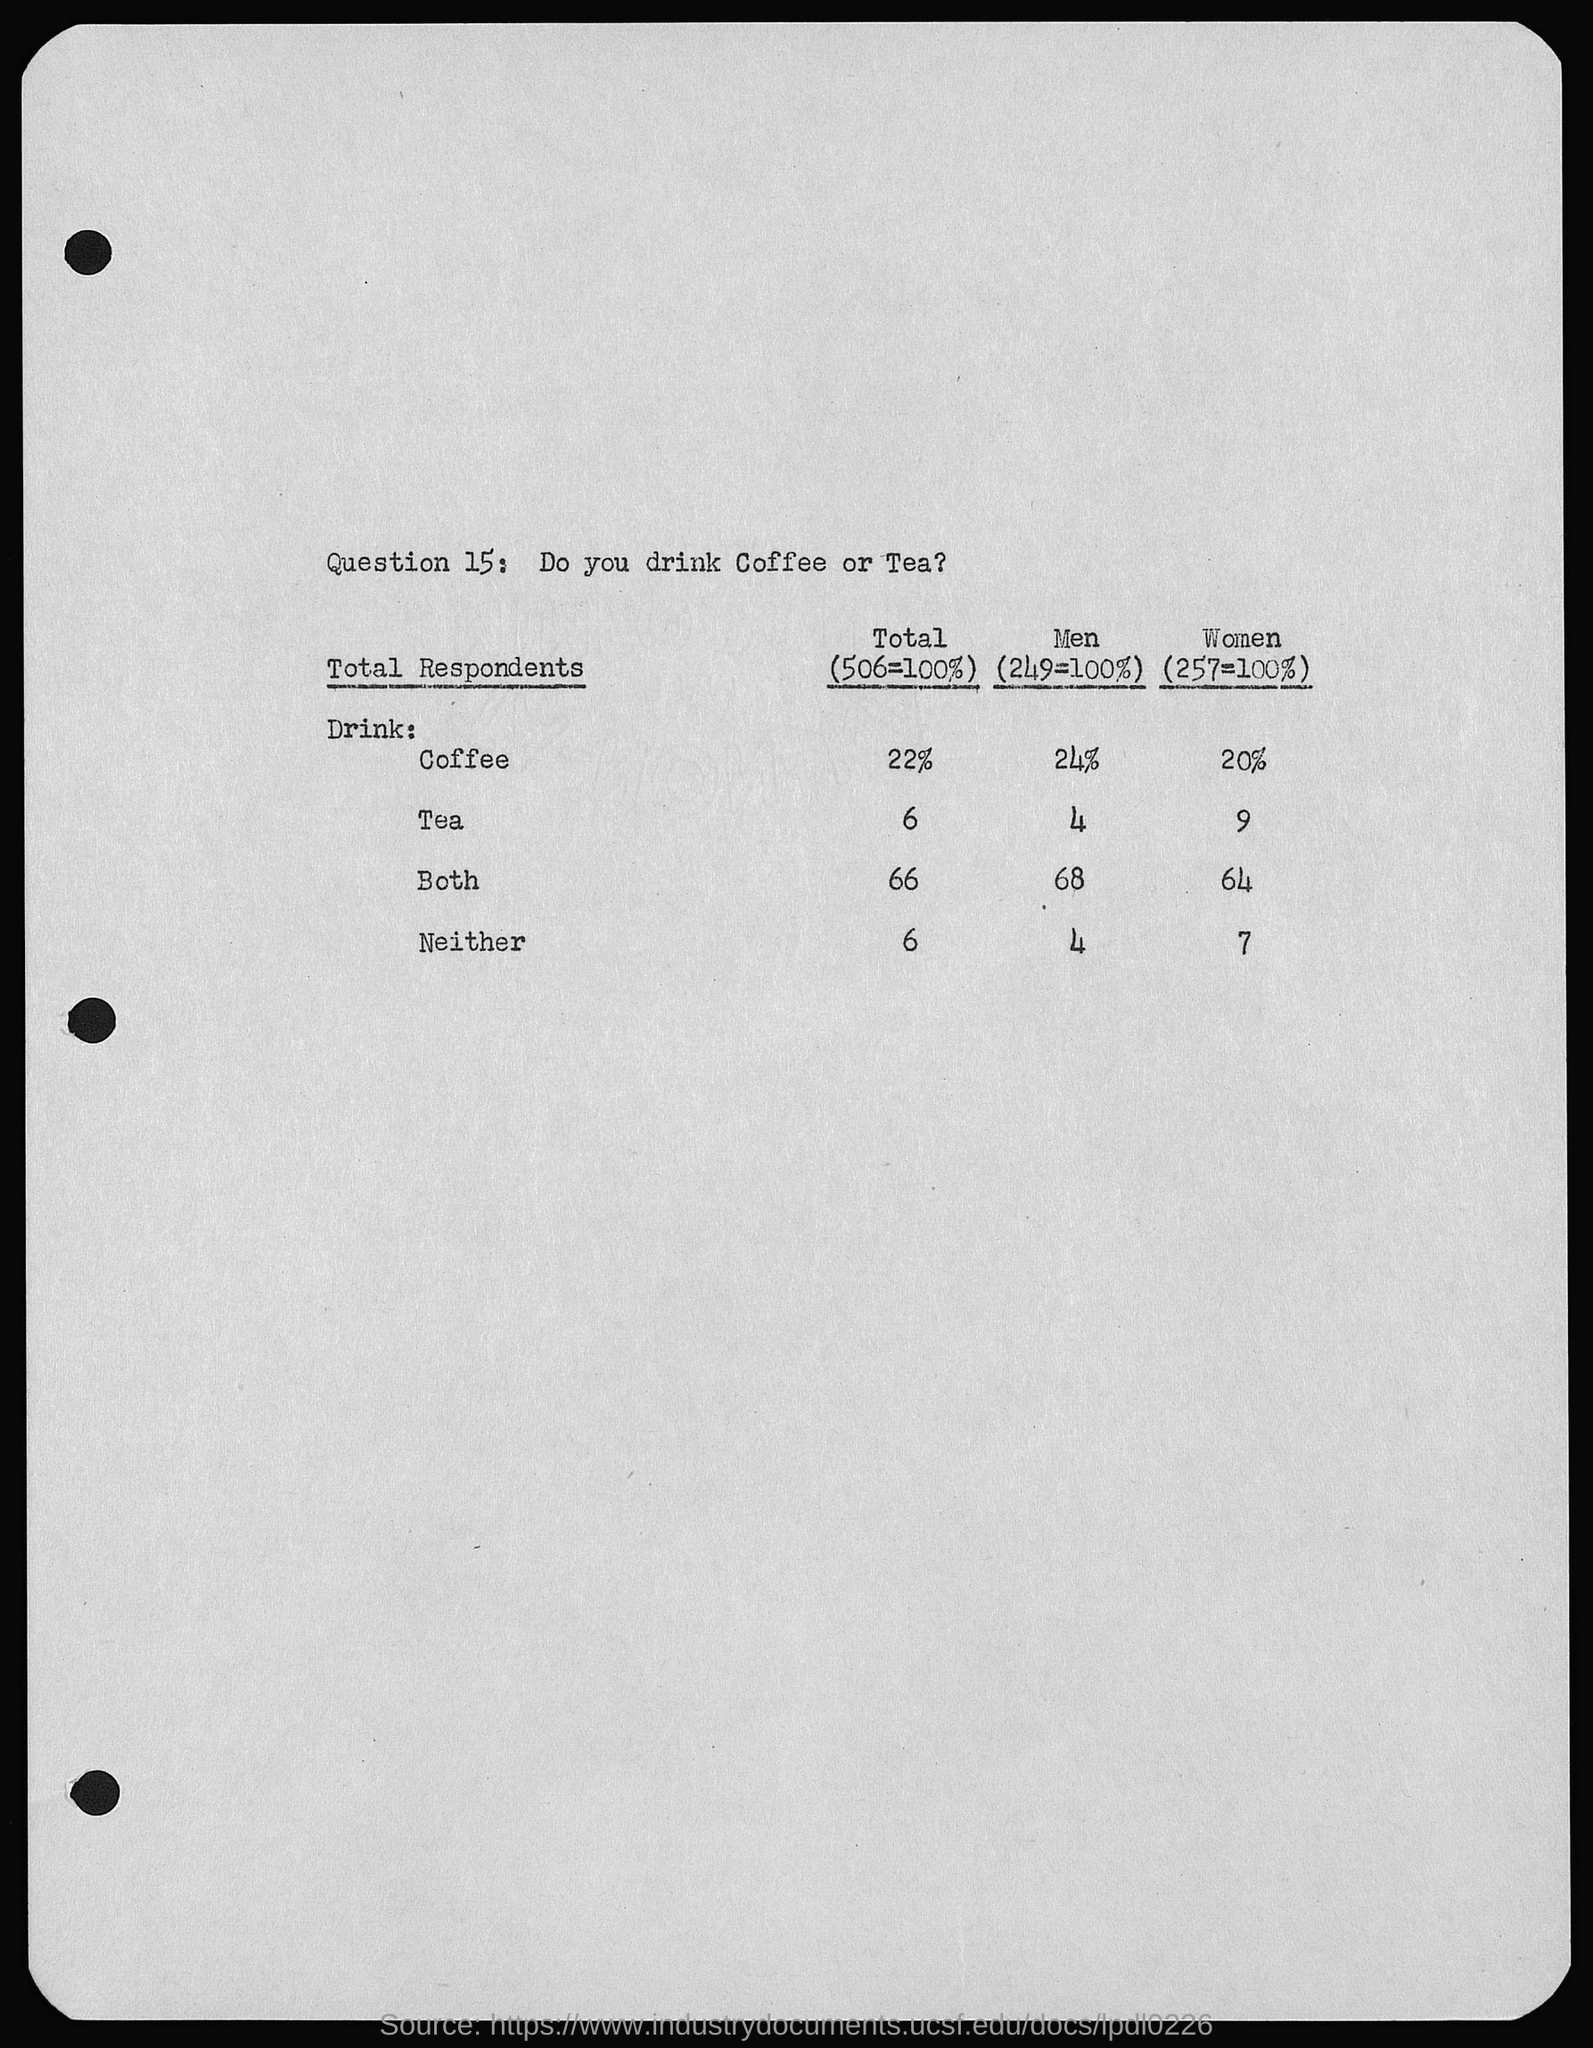Outline some significant characteristics in this image. What is question 15: I would like to know if you prefer to drink Coffee or Tea. Do you prefer Coffee or Tea? 